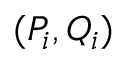<formula> <loc_0><loc_0><loc_500><loc_500>( P _ { i } , Q _ { i } )</formula> 